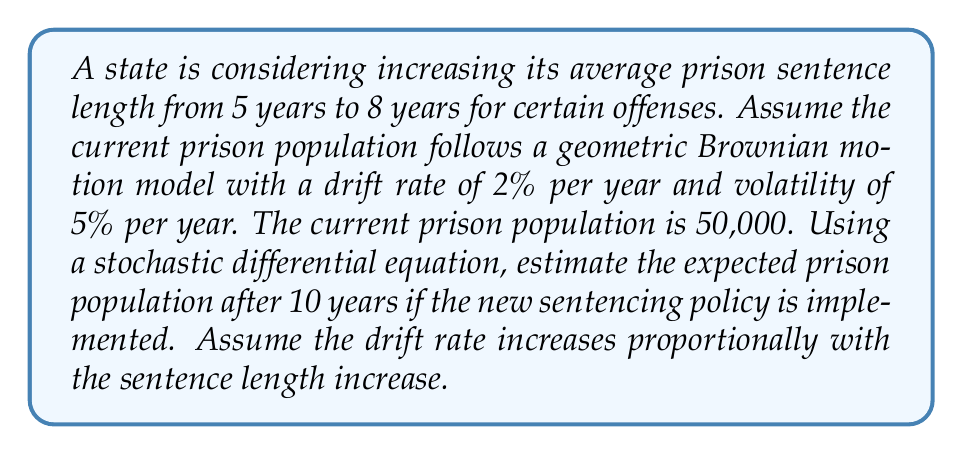Give your solution to this math problem. 1) First, we need to set up the stochastic differential equation (SDE) for geometric Brownian motion:

   $$dS_t = \mu S_t dt + \sigma S_t dW_t$$

   Where $S_t$ is the prison population at time $t$, $\mu$ is the drift rate, $\sigma$ is the volatility, and $W_t$ is a Wiener process.

2) Given:
   - Current drift rate ($\mu_1$) = 2% = 0.02
   - Volatility ($\sigma$) = 5% = 0.05
   - Initial population ($S_0$) = 50,000
   - Time period ($T$) = 10 years

3) The new sentencing policy increases average sentence length from 5 to 8 years, a factor of 8/5 = 1.6.
   We assume the drift rate increases proportionally:
   
   New drift rate ($\mu_2$) = 0.02 * (8/5) = 0.032 = 3.2%

4) The solution to the SDE for the expected value of $S_t$ is:

   $$E[S_t] = S_0 \exp(\mu t)$$

5) Plugging in our values:

   $$E[S_{10}] = 50,000 \exp(0.032 * 10)$$

6) Calculate:

   $$E[S_{10}] = 50,000 \exp(0.32) = 50,000 * 1.3771 = 68,855$$
Answer: 68,855 prisoners 